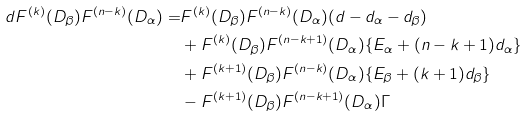<formula> <loc_0><loc_0><loc_500><loc_500>d F ^ { ( k ) } ( D _ { \beta } ) F ^ { ( n - k ) } ( D _ { \alpha } ) = & F ^ { ( k ) } ( D _ { \beta } ) F ^ { ( n - k ) } ( D _ { \alpha } ) ( d - d _ { \alpha } - d _ { \beta } ) \\ & + F ^ { ( k ) } ( D _ { \beta } ) F ^ { ( n - k + 1 ) } ( D _ { \alpha } ) \{ E _ { \alpha } + ( n - k + 1 ) d _ { \alpha } \} \\ & + F ^ { ( k + 1 ) } ( D _ { \beta } ) F ^ { ( n - k ) } ( D _ { \alpha } ) \{ E _ { \beta } + ( k + 1 ) d _ { \beta } \} \\ & - F ^ { ( k + 1 ) } ( D _ { \beta } ) F ^ { ( n - k + 1 ) } ( D _ { \alpha } ) \Gamma</formula> 